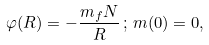Convert formula to latex. <formula><loc_0><loc_0><loc_500><loc_500>\varphi ( R ) = - \frac { m _ { f } N } { R } \, ; \, m ( 0 ) = 0 ,</formula> 